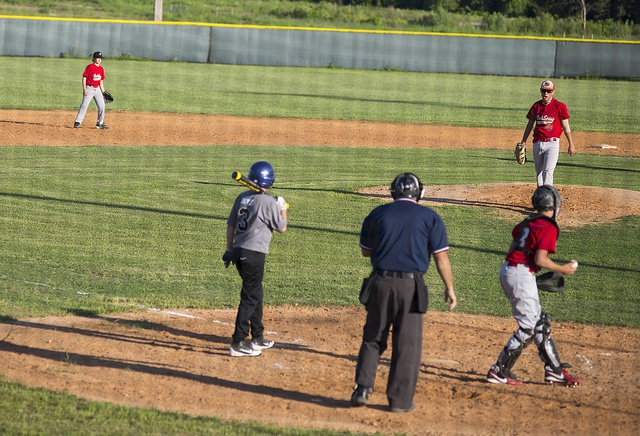Describe the objects in this image and their specific colors. I can see people in olive, black, gray, and navy tones, people in olive, black, gray, and lightgray tones, people in olive, black, darkgray, gray, and navy tones, people in olive, black, lightgray, gray, and brown tones, and people in olive, lightgray, red, gray, and black tones in this image. 